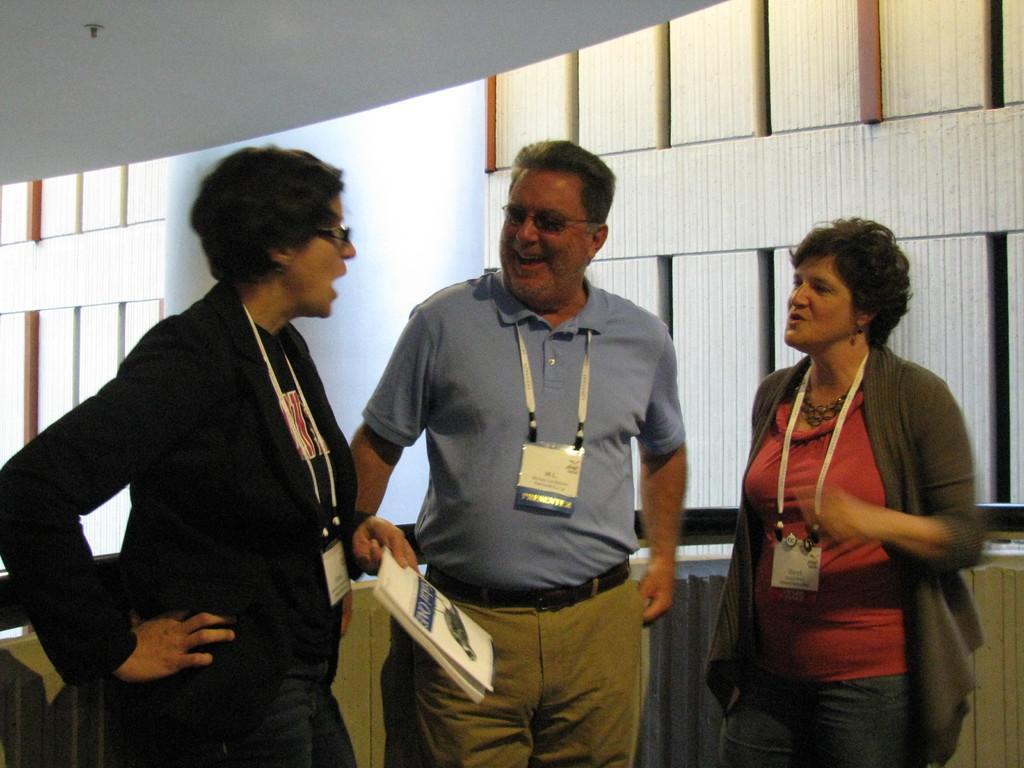Can you describe this image briefly? In this image we can see group of persons standing. One woman is holding a book in her hand. In the background, we can see the windows and the wall. 